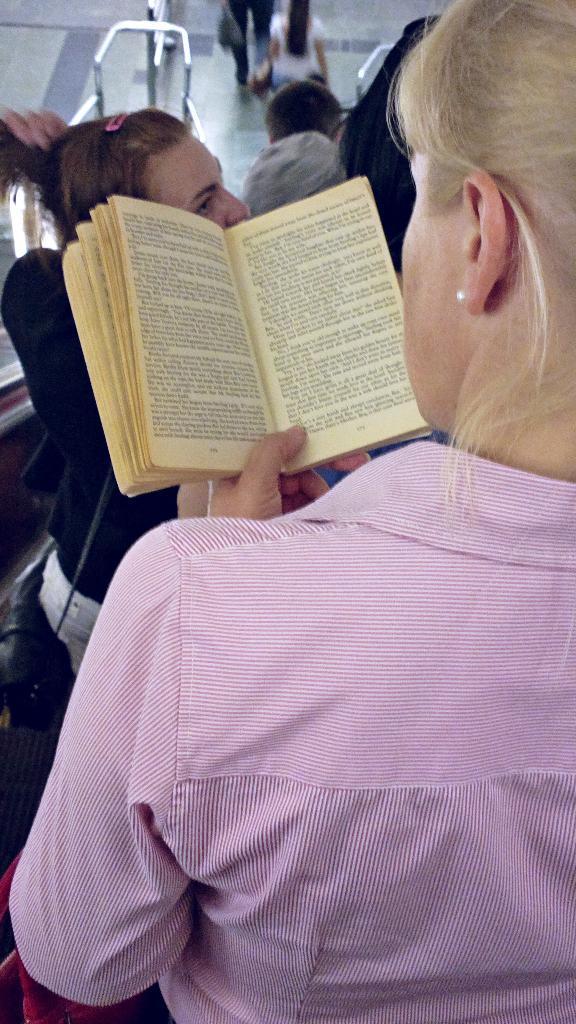Could you give a brief overview of what you see in this image? In this picture we can see a woman holding a book with her hand, some people, floor, bag and rods. 